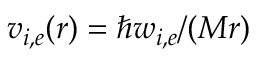Convert formula to latex. <formula><loc_0><loc_0><loc_500><loc_500>v _ { i , e } ( r ) = \hbar { w } _ { i , e } / ( M r )</formula> 